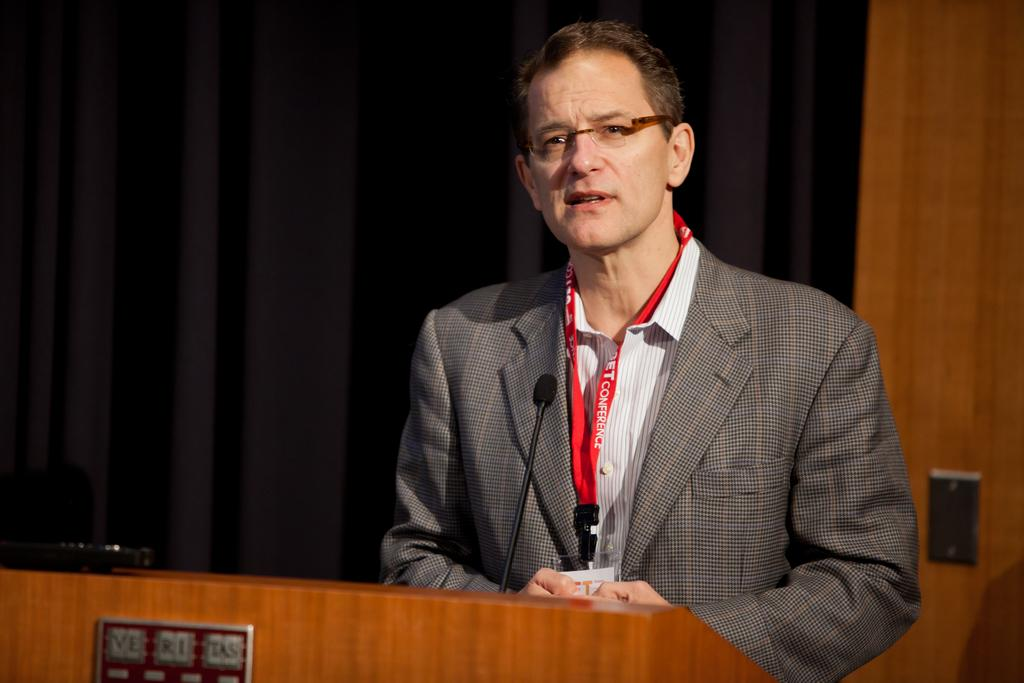What is the person in the image doing? There is a person standing and talking in the image. What object is present that might be used for amplifying the person's voice? There is a microphone in the image. What is on the podium in the image? There is an object on the podium, but its specific nature is not mentioned in the facts. What can be seen at the back of the image? There is a curtain at the back of the image. What type of wall is visible in the image? There is a wooden wall in the image. What type of stick is the person holding in the image? There is no stick present in the image; the person is holding a microphone. What hope does the person express in the image? The facts provided do not mention any specific hopes or emotions expressed by the person in the image. 